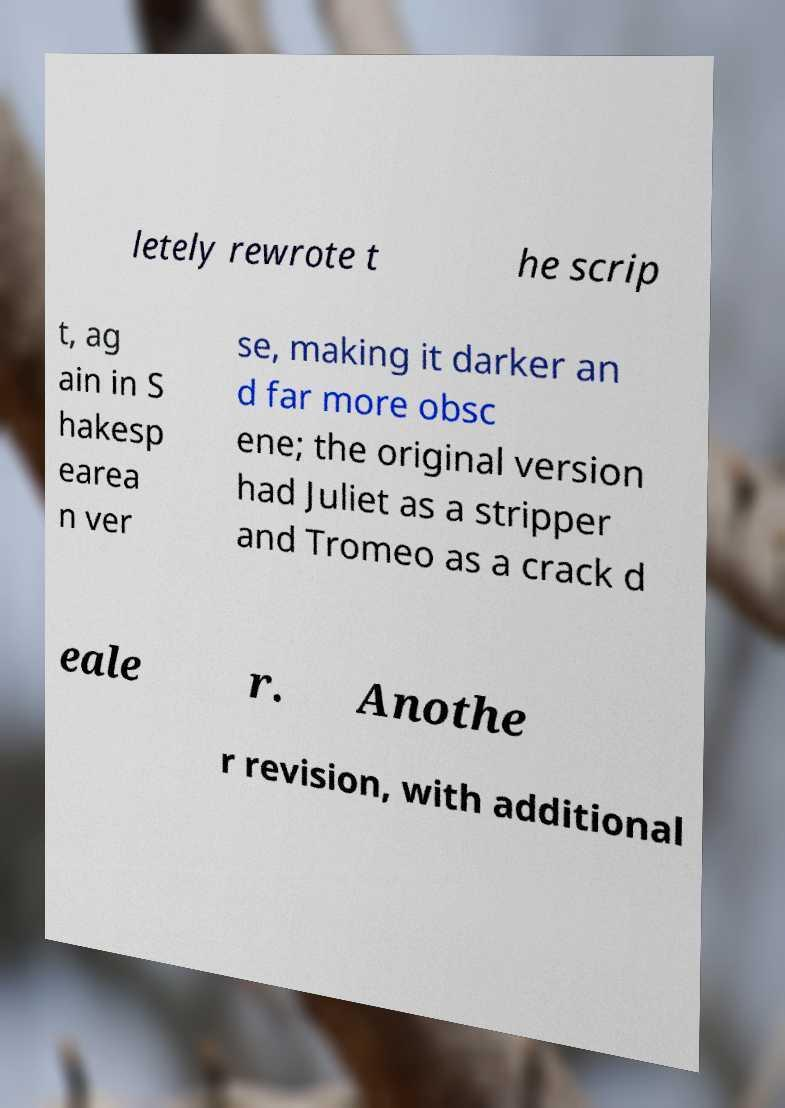Please read and relay the text visible in this image. What does it say? letely rewrote t he scrip t, ag ain in S hakesp earea n ver se, making it darker an d far more obsc ene; the original version had Juliet as a stripper and Tromeo as a crack d eale r. Anothe r revision, with additional 